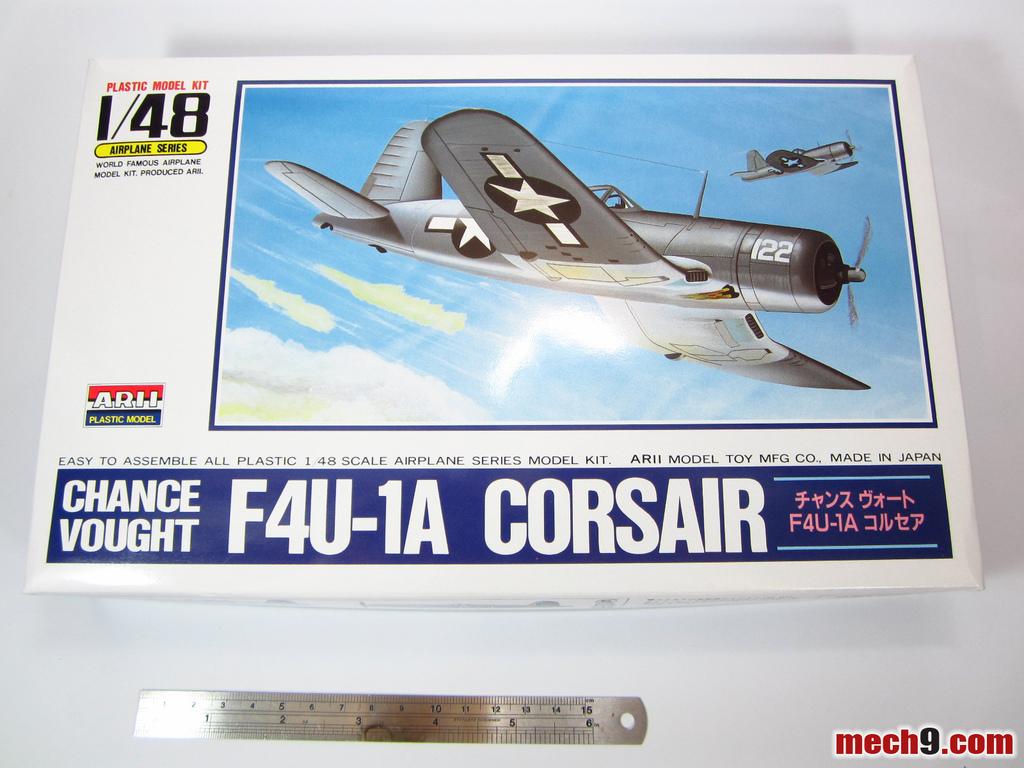What in the plane number?
Give a very brief answer. 122. How many planes are in the picture?
Provide a succinct answer. Answering does not require reading text in the image. 